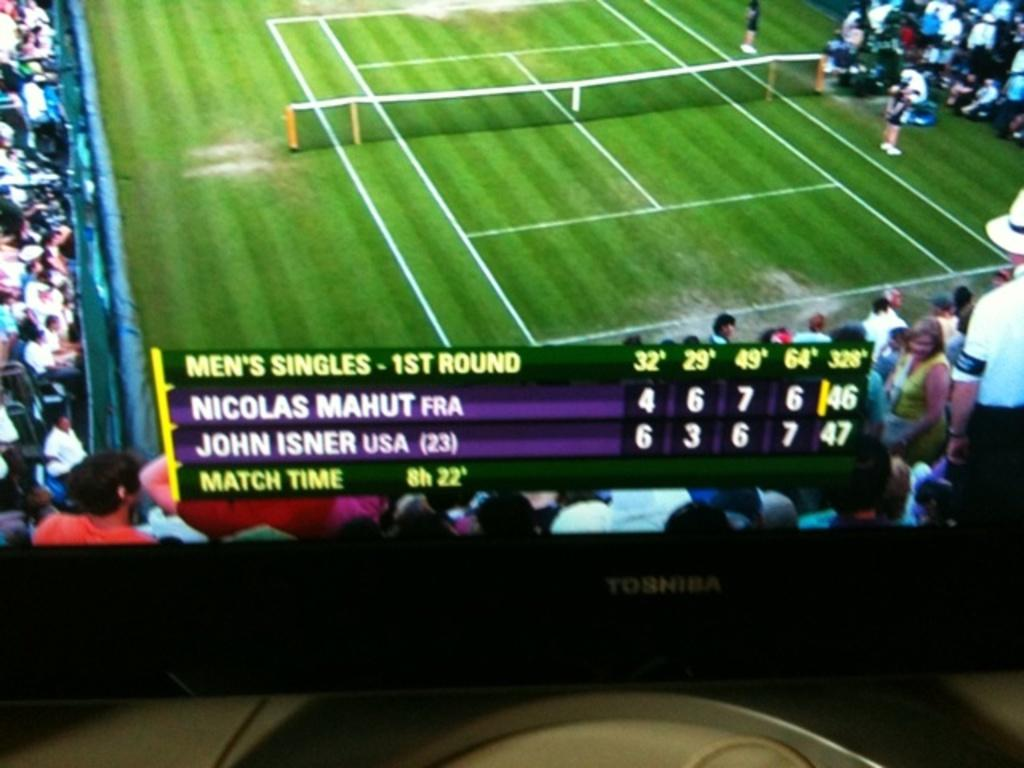<image>
Write a terse but informative summary of the picture. A tennis game of Men's Singles between MAHUT and ISNER. 